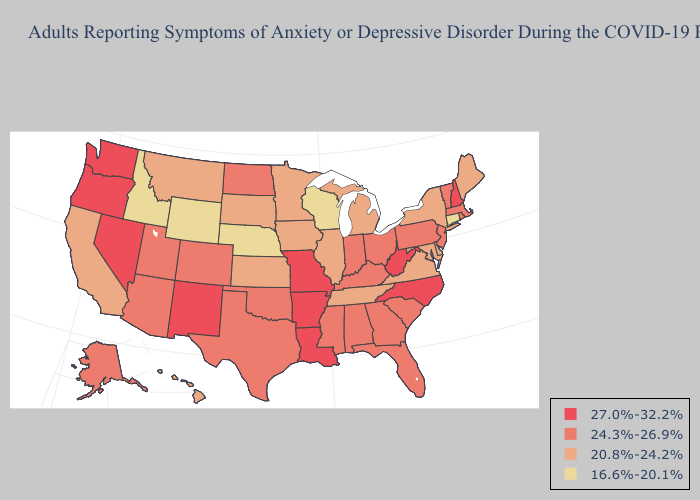Does Arizona have the same value as Montana?
Concise answer only. No. Does the map have missing data?
Answer briefly. No. Among the states that border Mississippi , does Tennessee have the lowest value?
Keep it brief. Yes. What is the highest value in the Northeast ?
Give a very brief answer. 27.0%-32.2%. Among the states that border Washington , which have the highest value?
Short answer required. Oregon. Name the states that have a value in the range 16.6%-20.1%?
Write a very short answer. Connecticut, Idaho, Nebraska, Wisconsin, Wyoming. Among the states that border Pennsylvania , which have the highest value?
Short answer required. West Virginia. What is the value of Idaho?
Keep it brief. 16.6%-20.1%. What is the value of Idaho?
Be succinct. 16.6%-20.1%. What is the value of Virginia?
Short answer required. 20.8%-24.2%. What is the value of Massachusetts?
Give a very brief answer. 24.3%-26.9%. Among the states that border Louisiana , does Arkansas have the lowest value?
Keep it brief. No. Name the states that have a value in the range 24.3%-26.9%?
Short answer required. Alabama, Alaska, Arizona, Colorado, Florida, Georgia, Indiana, Kentucky, Massachusetts, Mississippi, New Jersey, North Dakota, Ohio, Oklahoma, Pennsylvania, Rhode Island, South Carolina, Texas, Utah, Vermont. Name the states that have a value in the range 27.0%-32.2%?
Write a very short answer. Arkansas, Louisiana, Missouri, Nevada, New Hampshire, New Mexico, North Carolina, Oregon, Washington, West Virginia. Among the states that border Mississippi , which have the highest value?
Short answer required. Arkansas, Louisiana. 